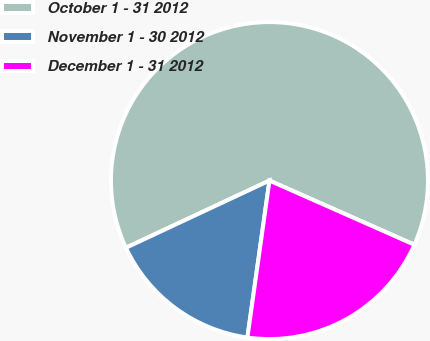<chart> <loc_0><loc_0><loc_500><loc_500><pie_chart><fcel>October 1 - 31 2012<fcel>November 1 - 30 2012<fcel>December 1 - 31 2012<nl><fcel>63.6%<fcel>15.81%<fcel>20.59%<nl></chart> 